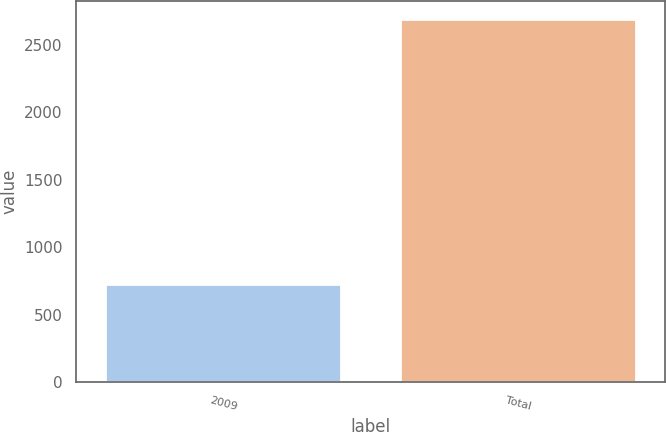Convert chart. <chart><loc_0><loc_0><loc_500><loc_500><bar_chart><fcel>2009<fcel>Total<nl><fcel>728<fcel>2692<nl></chart> 